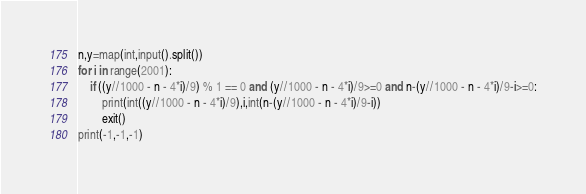Convert code to text. <code><loc_0><loc_0><loc_500><loc_500><_Python_>n,y=map(int,input().split())
for i in range(2001):
    if ((y//1000 - n - 4*i)/9) % 1 == 0 and (y//1000 - n - 4*i)/9>=0 and n-(y//1000 - n - 4*i)/9-i>=0:
        print(int((y//1000 - n - 4*i)/9),i,int(n-(y//1000 - n - 4*i)/9-i))
        exit()
print(-1,-1,-1)</code> 